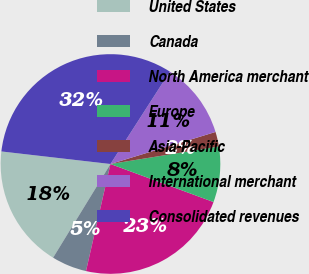Convert chart to OTSL. <chart><loc_0><loc_0><loc_500><loc_500><pie_chart><fcel>United States<fcel>Canada<fcel>North America merchant<fcel>Europe<fcel>Asia-Pacific<fcel>International merchant<fcel>Consolidated revenues<nl><fcel>18.08%<fcel>5.17%<fcel>22.95%<fcel>8.18%<fcel>2.16%<fcel>11.19%<fcel>32.27%<nl></chart> 